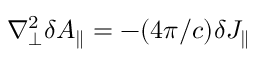<formula> <loc_0><loc_0><loc_500><loc_500>\nabla _ { \perp } ^ { 2 } \delta A _ { \| } = - ( 4 \pi / c ) \delta J _ { \| }</formula> 